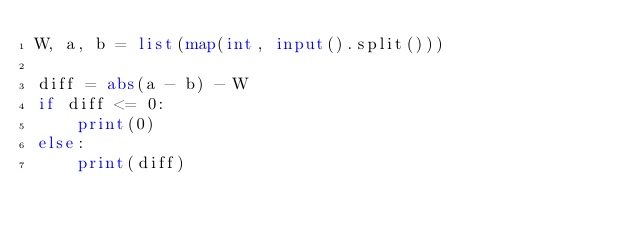<code> <loc_0><loc_0><loc_500><loc_500><_Python_>W, a, b = list(map(int, input().split()))

diff = abs(a - b) - W
if diff <= 0:
    print(0)
else:
    print(diff)
</code> 